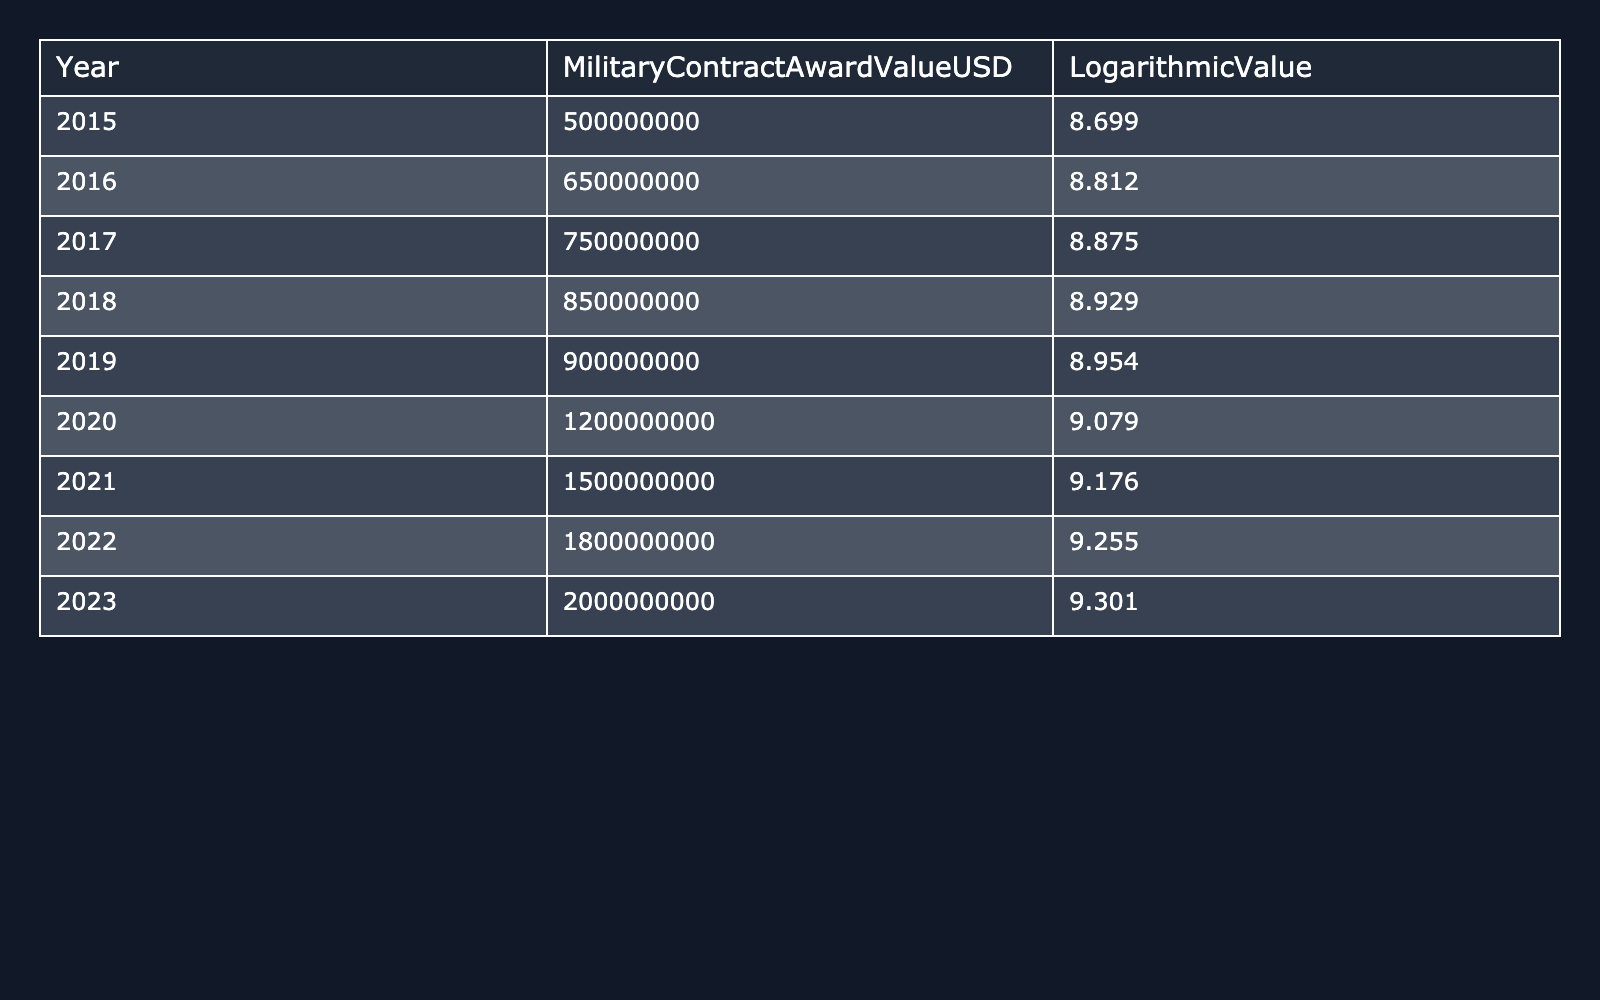What was the Military Contract Award Value in 2015? The table shows that the Military Contract Award Value for the year 2015 is 500,000,000 USD.
Answer: 500,000,000 USD What was the Logarithmic Value for 2020? According to the table, the Logarithmic Value for the year 2020 is 9.079.
Answer: 9.079 Which year had a Military Contract Award Value of 1,500,000,000 USD? The table indicates that the year with a Military Contract Award Value of 1,500,000,000 USD is 2021.
Answer: 2021 What is the difference in Military Contract Award Value between 2018 and 2019? The Military Contract Award Value for 2018 is 850,000,000 USD and for 2019 is 900,000,000 USD. The difference is 900,000,000 - 850,000,000 = 50,000,000 USD.
Answer: 50,000,000 USD What is the average Military Contract Award Value from 2015 to 2023? The values from 2015 to 2023 are: 500,000,000, 650,000,000, 750,000,000, 850,000,000, 900,000,000, 1,200,000,000, 1,500,000,000, 1,800,000,000, and 2,000,000,000. The sum is 9,300,000,000 USD, and there are 9 years: 9,300,000,000 / 9 = 1,033,333,333.33 USD.
Answer: 1,033,333,333.33 USD Is it true that the Logarithmic Value increased every year from 2015 to 2023? By examining the table, we see that the Logarithmic Value steadily increases each year from 8.699 in 2015 to 9.301 in 2023, confirming the statement is true.
Answer: Yes What is the total Military Contract Award Value for the three highest years (2021, 2022, and 2023)? The Military Contract Award Values for these years are: 1,500,000,000 (2021), 1,800,000,000 (2022), and 2,000,000,000 (2023). The total is 1,500,000,000 + 1,800,000,000 + 2,000,000,000 = 5,300,000,000 USD.
Answer: 5,300,000,000 USD Which year had the highest Logarithmic Value and what was it? The highest Logarithmic Value is 9.301 in the year 2023, according to the last entry in the table.
Answer: 2023, 9.301 What was the percentage increase in Military Contract Award Value from 2019 to 2020? The value in 2019 is 900,000,000 USD and in 2020 is 1,200,000,000 USD. The increase is (1,200,000,000 - 900,000,000) = 300,000,000 USD. The percentage is (300,000,000 / 900,000,000) * 100 = 33.33%.
Answer: 33.33% What year had a Logarithmic Value of 9.176? The table indicates that the year with a Logarithmic Value of 9.176 is 2021.
Answer: 2021 